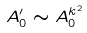<formula> <loc_0><loc_0><loc_500><loc_500>A _ { 0 } ^ { \prime } \sim A _ { 0 } ^ { k ^ { 2 } }</formula> 